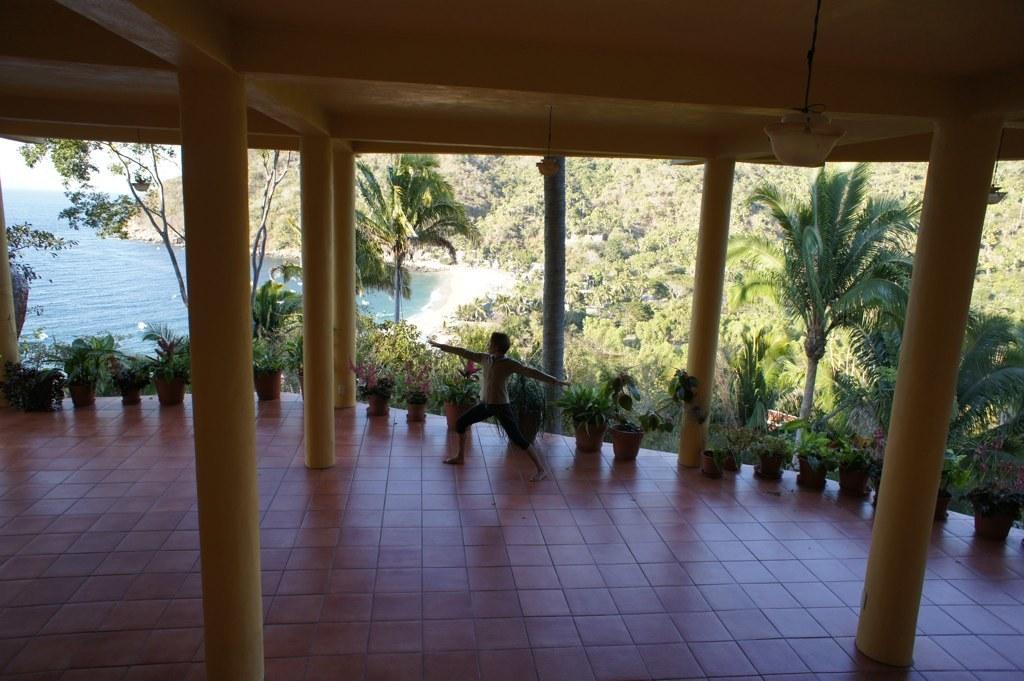What is the primary subject in the image? There is a person standing in the image. Where is the person standing? The person is standing on the floor. What type of vegetation can be seen in the image? There are house plants and trees in the image. What architectural features are present in the image? There are pillars and a roof in the image. What natural feature is visible in the image? The ocean is visible in the image. What type of digestion issues is the person experiencing in the image? There is no indication of any digestion issues in the image; it simply shows a person standing. 